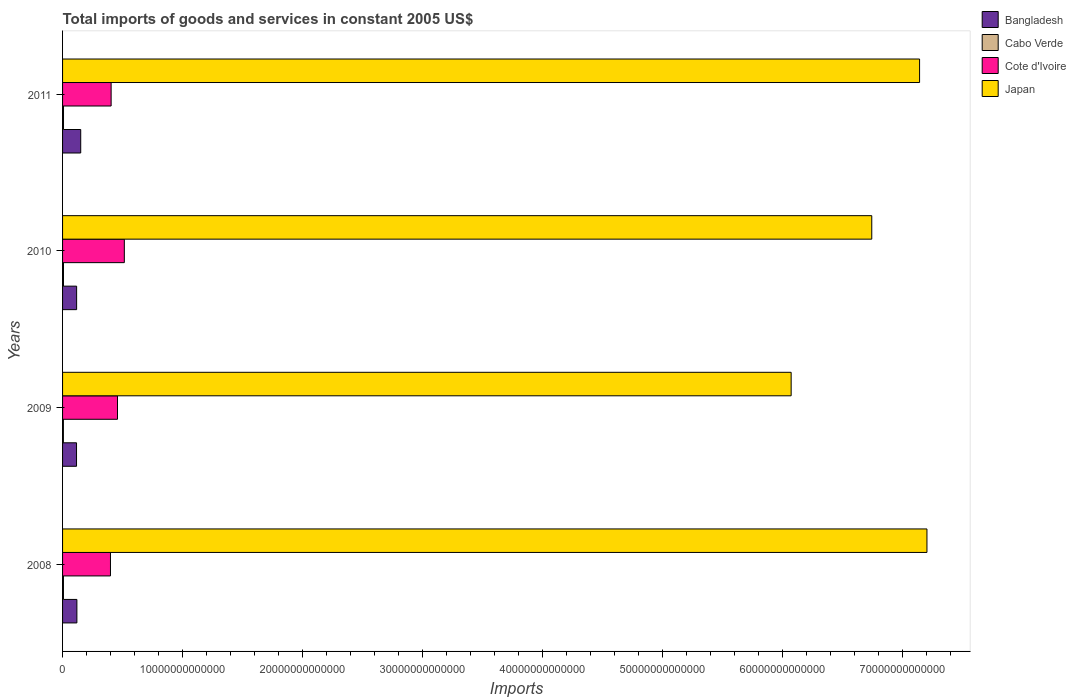How many different coloured bars are there?
Make the answer very short. 4. How many bars are there on the 3rd tick from the top?
Provide a short and direct response. 4. How many bars are there on the 1st tick from the bottom?
Your answer should be compact. 4. What is the label of the 1st group of bars from the top?
Offer a terse response. 2011. In how many cases, is the number of bars for a given year not equal to the number of legend labels?
Your response must be concise. 0. What is the total imports of goods and services in Cabo Verde in 2008?
Make the answer very short. 7.44e+1. Across all years, what is the maximum total imports of goods and services in Cabo Verde?
Offer a terse response. 7.97e+1. Across all years, what is the minimum total imports of goods and services in Cabo Verde?
Your answer should be compact. 6.96e+1. What is the total total imports of goods and services in Cote d'Ivoire in the graph?
Your answer should be compact. 1.78e+13. What is the difference between the total imports of goods and services in Cote d'Ivoire in 2008 and that in 2010?
Offer a terse response. -1.15e+12. What is the difference between the total imports of goods and services in Cote d'Ivoire in 2010 and the total imports of goods and services in Japan in 2011?
Your answer should be compact. -6.63e+13. What is the average total imports of goods and services in Cabo Verde per year?
Ensure brevity in your answer.  7.50e+1. In the year 2008, what is the difference between the total imports of goods and services in Cabo Verde and total imports of goods and services in Cote d'Ivoire?
Your answer should be very brief. -3.92e+12. What is the ratio of the total imports of goods and services in Cote d'Ivoire in 2008 to that in 2011?
Offer a terse response. 0.99. Is the total imports of goods and services in Bangladesh in 2010 less than that in 2011?
Give a very brief answer. Yes. What is the difference between the highest and the second highest total imports of goods and services in Bangladesh?
Keep it short and to the point. 3.18e+11. What is the difference between the highest and the lowest total imports of goods and services in Cabo Verde?
Make the answer very short. 1.01e+1. In how many years, is the total imports of goods and services in Cabo Verde greater than the average total imports of goods and services in Cabo Verde taken over all years?
Your response must be concise. 2. Is the sum of the total imports of goods and services in Cabo Verde in 2009 and 2011 greater than the maximum total imports of goods and services in Japan across all years?
Offer a very short reply. No. Is it the case that in every year, the sum of the total imports of goods and services in Japan and total imports of goods and services in Cabo Verde is greater than the sum of total imports of goods and services in Bangladesh and total imports of goods and services in Cote d'Ivoire?
Make the answer very short. Yes. What does the 3rd bar from the bottom in 2008 represents?
Offer a terse response. Cote d'Ivoire. How many bars are there?
Offer a terse response. 16. Are all the bars in the graph horizontal?
Give a very brief answer. Yes. How many years are there in the graph?
Provide a short and direct response. 4. What is the difference between two consecutive major ticks on the X-axis?
Offer a terse response. 1.00e+13. Are the values on the major ticks of X-axis written in scientific E-notation?
Your answer should be very brief. No. Does the graph contain any zero values?
Offer a very short reply. No. Where does the legend appear in the graph?
Your answer should be very brief. Top right. What is the title of the graph?
Provide a short and direct response. Total imports of goods and services in constant 2005 US$. Does "Turkmenistan" appear as one of the legend labels in the graph?
Your answer should be very brief. No. What is the label or title of the X-axis?
Your response must be concise. Imports. What is the Imports in Bangladesh in 2008?
Keep it short and to the point. 1.19e+12. What is the Imports of Cabo Verde in 2008?
Your answer should be very brief. 7.44e+1. What is the Imports in Cote d'Ivoire in 2008?
Keep it short and to the point. 3.99e+12. What is the Imports in Japan in 2008?
Provide a succinct answer. 7.20e+13. What is the Imports of Bangladesh in 2009?
Make the answer very short. 1.16e+12. What is the Imports of Cabo Verde in 2009?
Your response must be concise. 6.96e+1. What is the Imports in Cote d'Ivoire in 2009?
Keep it short and to the point. 4.58e+12. What is the Imports of Japan in 2009?
Offer a very short reply. 6.07e+13. What is the Imports of Bangladesh in 2010?
Your answer should be compact. 1.17e+12. What is the Imports in Cabo Verde in 2010?
Provide a succinct answer. 7.64e+1. What is the Imports in Cote d'Ivoire in 2010?
Your answer should be very brief. 5.15e+12. What is the Imports in Japan in 2010?
Provide a short and direct response. 6.74e+13. What is the Imports of Bangladesh in 2011?
Give a very brief answer. 1.51e+12. What is the Imports of Cabo Verde in 2011?
Make the answer very short. 7.97e+1. What is the Imports in Cote d'Ivoire in 2011?
Keep it short and to the point. 4.05e+12. What is the Imports of Japan in 2011?
Give a very brief answer. 7.14e+13. Across all years, what is the maximum Imports in Bangladesh?
Your answer should be compact. 1.51e+12. Across all years, what is the maximum Imports of Cabo Verde?
Give a very brief answer. 7.97e+1. Across all years, what is the maximum Imports of Cote d'Ivoire?
Provide a succinct answer. 5.15e+12. Across all years, what is the maximum Imports of Japan?
Provide a succinct answer. 7.20e+13. Across all years, what is the minimum Imports in Bangladesh?
Your answer should be compact. 1.16e+12. Across all years, what is the minimum Imports in Cabo Verde?
Offer a terse response. 6.96e+1. Across all years, what is the minimum Imports in Cote d'Ivoire?
Give a very brief answer. 3.99e+12. Across all years, what is the minimum Imports in Japan?
Provide a short and direct response. 6.07e+13. What is the total Imports of Bangladesh in the graph?
Give a very brief answer. 5.04e+12. What is the total Imports of Cabo Verde in the graph?
Give a very brief answer. 3.00e+11. What is the total Imports of Cote d'Ivoire in the graph?
Provide a short and direct response. 1.78e+13. What is the total Imports in Japan in the graph?
Your answer should be very brief. 2.72e+14. What is the difference between the Imports of Bangladesh in 2008 and that in 2009?
Your answer should be very brief. 3.10e+1. What is the difference between the Imports in Cabo Verde in 2008 and that in 2009?
Provide a short and direct response. 4.79e+09. What is the difference between the Imports of Cote d'Ivoire in 2008 and that in 2009?
Keep it short and to the point. -5.86e+11. What is the difference between the Imports in Japan in 2008 and that in 2009?
Keep it short and to the point. 1.13e+13. What is the difference between the Imports in Bangladesh in 2008 and that in 2010?
Ensure brevity in your answer.  2.31e+1. What is the difference between the Imports of Cabo Verde in 2008 and that in 2010?
Offer a terse response. -1.97e+09. What is the difference between the Imports of Cote d'Ivoire in 2008 and that in 2010?
Ensure brevity in your answer.  -1.15e+12. What is the difference between the Imports of Japan in 2008 and that in 2010?
Offer a very short reply. 4.60e+12. What is the difference between the Imports of Bangladesh in 2008 and that in 2011?
Offer a very short reply. -3.18e+11. What is the difference between the Imports in Cabo Verde in 2008 and that in 2011?
Your response must be concise. -5.29e+09. What is the difference between the Imports of Cote d'Ivoire in 2008 and that in 2011?
Ensure brevity in your answer.  -5.56e+1. What is the difference between the Imports in Japan in 2008 and that in 2011?
Your answer should be very brief. 6.15e+11. What is the difference between the Imports in Bangladesh in 2009 and that in 2010?
Provide a succinct answer. -7.98e+09. What is the difference between the Imports in Cabo Verde in 2009 and that in 2010?
Your response must be concise. -6.77e+09. What is the difference between the Imports of Cote d'Ivoire in 2009 and that in 2010?
Your answer should be very brief. -5.69e+11. What is the difference between the Imports in Japan in 2009 and that in 2010?
Ensure brevity in your answer.  -6.72e+12. What is the difference between the Imports in Bangladesh in 2009 and that in 2011?
Your answer should be compact. -3.49e+11. What is the difference between the Imports in Cabo Verde in 2009 and that in 2011?
Give a very brief answer. -1.01e+1. What is the difference between the Imports of Cote d'Ivoire in 2009 and that in 2011?
Keep it short and to the point. 5.30e+11. What is the difference between the Imports of Japan in 2009 and that in 2011?
Your response must be concise. -1.07e+13. What is the difference between the Imports in Bangladesh in 2010 and that in 2011?
Provide a short and direct response. -3.41e+11. What is the difference between the Imports of Cabo Verde in 2010 and that in 2011?
Provide a short and direct response. -3.32e+09. What is the difference between the Imports in Cote d'Ivoire in 2010 and that in 2011?
Your answer should be compact. 1.10e+12. What is the difference between the Imports in Japan in 2010 and that in 2011?
Give a very brief answer. -3.98e+12. What is the difference between the Imports of Bangladesh in 2008 and the Imports of Cabo Verde in 2009?
Your answer should be compact. 1.12e+12. What is the difference between the Imports of Bangladesh in 2008 and the Imports of Cote d'Ivoire in 2009?
Give a very brief answer. -3.38e+12. What is the difference between the Imports in Bangladesh in 2008 and the Imports in Japan in 2009?
Offer a very short reply. -5.95e+13. What is the difference between the Imports in Cabo Verde in 2008 and the Imports in Cote d'Ivoire in 2009?
Your answer should be compact. -4.50e+12. What is the difference between the Imports in Cabo Verde in 2008 and the Imports in Japan in 2009?
Make the answer very short. -6.06e+13. What is the difference between the Imports in Cote d'Ivoire in 2008 and the Imports in Japan in 2009?
Make the answer very short. -5.67e+13. What is the difference between the Imports of Bangladesh in 2008 and the Imports of Cabo Verde in 2010?
Keep it short and to the point. 1.12e+12. What is the difference between the Imports of Bangladesh in 2008 and the Imports of Cote d'Ivoire in 2010?
Provide a succinct answer. -3.95e+12. What is the difference between the Imports in Bangladesh in 2008 and the Imports in Japan in 2010?
Give a very brief answer. -6.62e+13. What is the difference between the Imports of Cabo Verde in 2008 and the Imports of Cote d'Ivoire in 2010?
Make the answer very short. -5.07e+12. What is the difference between the Imports in Cabo Verde in 2008 and the Imports in Japan in 2010?
Your answer should be compact. -6.73e+13. What is the difference between the Imports in Cote d'Ivoire in 2008 and the Imports in Japan in 2010?
Make the answer very short. -6.34e+13. What is the difference between the Imports of Bangladesh in 2008 and the Imports of Cabo Verde in 2011?
Ensure brevity in your answer.  1.11e+12. What is the difference between the Imports in Bangladesh in 2008 and the Imports in Cote d'Ivoire in 2011?
Provide a succinct answer. -2.85e+12. What is the difference between the Imports of Bangladesh in 2008 and the Imports of Japan in 2011?
Keep it short and to the point. -7.02e+13. What is the difference between the Imports of Cabo Verde in 2008 and the Imports of Cote d'Ivoire in 2011?
Your response must be concise. -3.97e+12. What is the difference between the Imports of Cabo Verde in 2008 and the Imports of Japan in 2011?
Ensure brevity in your answer.  -7.13e+13. What is the difference between the Imports in Cote d'Ivoire in 2008 and the Imports in Japan in 2011?
Keep it short and to the point. -6.74e+13. What is the difference between the Imports in Bangladesh in 2009 and the Imports in Cabo Verde in 2010?
Ensure brevity in your answer.  1.09e+12. What is the difference between the Imports of Bangladesh in 2009 and the Imports of Cote d'Ivoire in 2010?
Give a very brief answer. -3.98e+12. What is the difference between the Imports in Bangladesh in 2009 and the Imports in Japan in 2010?
Your response must be concise. -6.63e+13. What is the difference between the Imports of Cabo Verde in 2009 and the Imports of Cote d'Ivoire in 2010?
Offer a very short reply. -5.08e+12. What is the difference between the Imports of Cabo Verde in 2009 and the Imports of Japan in 2010?
Provide a succinct answer. -6.73e+13. What is the difference between the Imports in Cote d'Ivoire in 2009 and the Imports in Japan in 2010?
Offer a terse response. -6.28e+13. What is the difference between the Imports in Bangladesh in 2009 and the Imports in Cabo Verde in 2011?
Offer a terse response. 1.08e+12. What is the difference between the Imports of Bangladesh in 2009 and the Imports of Cote d'Ivoire in 2011?
Offer a terse response. -2.88e+12. What is the difference between the Imports in Bangladesh in 2009 and the Imports in Japan in 2011?
Offer a very short reply. -7.02e+13. What is the difference between the Imports of Cabo Verde in 2009 and the Imports of Cote d'Ivoire in 2011?
Give a very brief answer. -3.98e+12. What is the difference between the Imports of Cabo Verde in 2009 and the Imports of Japan in 2011?
Offer a terse response. -7.13e+13. What is the difference between the Imports of Cote d'Ivoire in 2009 and the Imports of Japan in 2011?
Your answer should be compact. -6.68e+13. What is the difference between the Imports of Bangladesh in 2010 and the Imports of Cabo Verde in 2011?
Your answer should be very brief. 1.09e+12. What is the difference between the Imports of Bangladesh in 2010 and the Imports of Cote d'Ivoire in 2011?
Offer a terse response. -2.88e+12. What is the difference between the Imports of Bangladesh in 2010 and the Imports of Japan in 2011?
Offer a terse response. -7.02e+13. What is the difference between the Imports of Cabo Verde in 2010 and the Imports of Cote d'Ivoire in 2011?
Provide a short and direct response. -3.97e+12. What is the difference between the Imports of Cabo Verde in 2010 and the Imports of Japan in 2011?
Offer a terse response. -7.13e+13. What is the difference between the Imports in Cote d'Ivoire in 2010 and the Imports in Japan in 2011?
Provide a short and direct response. -6.63e+13. What is the average Imports of Bangladesh per year?
Give a very brief answer. 1.26e+12. What is the average Imports in Cabo Verde per year?
Make the answer very short. 7.50e+1. What is the average Imports of Cote d'Ivoire per year?
Your response must be concise. 4.44e+12. What is the average Imports of Japan per year?
Give a very brief answer. 6.79e+13. In the year 2008, what is the difference between the Imports in Bangladesh and Imports in Cabo Verde?
Ensure brevity in your answer.  1.12e+12. In the year 2008, what is the difference between the Imports in Bangladesh and Imports in Cote d'Ivoire?
Your answer should be very brief. -2.80e+12. In the year 2008, what is the difference between the Imports of Bangladesh and Imports of Japan?
Your answer should be very brief. -7.08e+13. In the year 2008, what is the difference between the Imports of Cabo Verde and Imports of Cote d'Ivoire?
Offer a terse response. -3.92e+12. In the year 2008, what is the difference between the Imports in Cabo Verde and Imports in Japan?
Provide a short and direct response. -7.19e+13. In the year 2008, what is the difference between the Imports in Cote d'Ivoire and Imports in Japan?
Ensure brevity in your answer.  -6.80e+13. In the year 2009, what is the difference between the Imports of Bangladesh and Imports of Cabo Verde?
Offer a very short reply. 1.09e+12. In the year 2009, what is the difference between the Imports of Bangladesh and Imports of Cote d'Ivoire?
Your answer should be compact. -3.41e+12. In the year 2009, what is the difference between the Imports in Bangladesh and Imports in Japan?
Offer a terse response. -5.95e+13. In the year 2009, what is the difference between the Imports of Cabo Verde and Imports of Cote d'Ivoire?
Offer a very short reply. -4.51e+12. In the year 2009, what is the difference between the Imports of Cabo Verde and Imports of Japan?
Ensure brevity in your answer.  -6.06e+13. In the year 2009, what is the difference between the Imports in Cote d'Ivoire and Imports in Japan?
Your answer should be compact. -5.61e+13. In the year 2010, what is the difference between the Imports in Bangladesh and Imports in Cabo Verde?
Provide a succinct answer. 1.09e+12. In the year 2010, what is the difference between the Imports of Bangladesh and Imports of Cote d'Ivoire?
Ensure brevity in your answer.  -3.97e+12. In the year 2010, what is the difference between the Imports in Bangladesh and Imports in Japan?
Your answer should be very brief. -6.62e+13. In the year 2010, what is the difference between the Imports in Cabo Verde and Imports in Cote d'Ivoire?
Your answer should be compact. -5.07e+12. In the year 2010, what is the difference between the Imports of Cabo Verde and Imports of Japan?
Your answer should be very brief. -6.73e+13. In the year 2010, what is the difference between the Imports of Cote d'Ivoire and Imports of Japan?
Offer a very short reply. -6.23e+13. In the year 2011, what is the difference between the Imports of Bangladesh and Imports of Cabo Verde?
Offer a terse response. 1.43e+12. In the year 2011, what is the difference between the Imports of Bangladesh and Imports of Cote d'Ivoire?
Offer a very short reply. -2.53e+12. In the year 2011, what is the difference between the Imports of Bangladesh and Imports of Japan?
Your answer should be very brief. -6.99e+13. In the year 2011, what is the difference between the Imports in Cabo Verde and Imports in Cote d'Ivoire?
Ensure brevity in your answer.  -3.97e+12. In the year 2011, what is the difference between the Imports in Cabo Verde and Imports in Japan?
Keep it short and to the point. -7.13e+13. In the year 2011, what is the difference between the Imports in Cote d'Ivoire and Imports in Japan?
Give a very brief answer. -6.74e+13. What is the ratio of the Imports in Bangladesh in 2008 to that in 2009?
Offer a terse response. 1.03. What is the ratio of the Imports of Cabo Verde in 2008 to that in 2009?
Offer a terse response. 1.07. What is the ratio of the Imports of Cote d'Ivoire in 2008 to that in 2009?
Provide a short and direct response. 0.87. What is the ratio of the Imports in Japan in 2008 to that in 2009?
Your answer should be very brief. 1.19. What is the ratio of the Imports of Bangladesh in 2008 to that in 2010?
Your response must be concise. 1.02. What is the ratio of the Imports in Cabo Verde in 2008 to that in 2010?
Provide a short and direct response. 0.97. What is the ratio of the Imports in Cote d'Ivoire in 2008 to that in 2010?
Your answer should be very brief. 0.78. What is the ratio of the Imports of Japan in 2008 to that in 2010?
Offer a terse response. 1.07. What is the ratio of the Imports in Bangladesh in 2008 to that in 2011?
Provide a short and direct response. 0.79. What is the ratio of the Imports in Cabo Verde in 2008 to that in 2011?
Provide a succinct answer. 0.93. What is the ratio of the Imports of Cote d'Ivoire in 2008 to that in 2011?
Your answer should be compact. 0.99. What is the ratio of the Imports in Japan in 2008 to that in 2011?
Provide a short and direct response. 1.01. What is the ratio of the Imports in Cabo Verde in 2009 to that in 2010?
Provide a short and direct response. 0.91. What is the ratio of the Imports in Cote d'Ivoire in 2009 to that in 2010?
Ensure brevity in your answer.  0.89. What is the ratio of the Imports in Japan in 2009 to that in 2010?
Your answer should be very brief. 0.9. What is the ratio of the Imports of Bangladesh in 2009 to that in 2011?
Offer a terse response. 0.77. What is the ratio of the Imports of Cabo Verde in 2009 to that in 2011?
Keep it short and to the point. 0.87. What is the ratio of the Imports of Cote d'Ivoire in 2009 to that in 2011?
Make the answer very short. 1.13. What is the ratio of the Imports of Japan in 2009 to that in 2011?
Keep it short and to the point. 0.85. What is the ratio of the Imports of Bangladesh in 2010 to that in 2011?
Provide a succinct answer. 0.77. What is the ratio of the Imports in Cabo Verde in 2010 to that in 2011?
Your answer should be very brief. 0.96. What is the ratio of the Imports in Cote d'Ivoire in 2010 to that in 2011?
Offer a terse response. 1.27. What is the ratio of the Imports of Japan in 2010 to that in 2011?
Your answer should be very brief. 0.94. What is the difference between the highest and the second highest Imports of Bangladesh?
Give a very brief answer. 3.18e+11. What is the difference between the highest and the second highest Imports in Cabo Verde?
Give a very brief answer. 3.32e+09. What is the difference between the highest and the second highest Imports in Cote d'Ivoire?
Your answer should be very brief. 5.69e+11. What is the difference between the highest and the second highest Imports in Japan?
Keep it short and to the point. 6.15e+11. What is the difference between the highest and the lowest Imports in Bangladesh?
Your response must be concise. 3.49e+11. What is the difference between the highest and the lowest Imports of Cabo Verde?
Keep it short and to the point. 1.01e+1. What is the difference between the highest and the lowest Imports in Cote d'Ivoire?
Your answer should be compact. 1.15e+12. What is the difference between the highest and the lowest Imports of Japan?
Ensure brevity in your answer.  1.13e+13. 